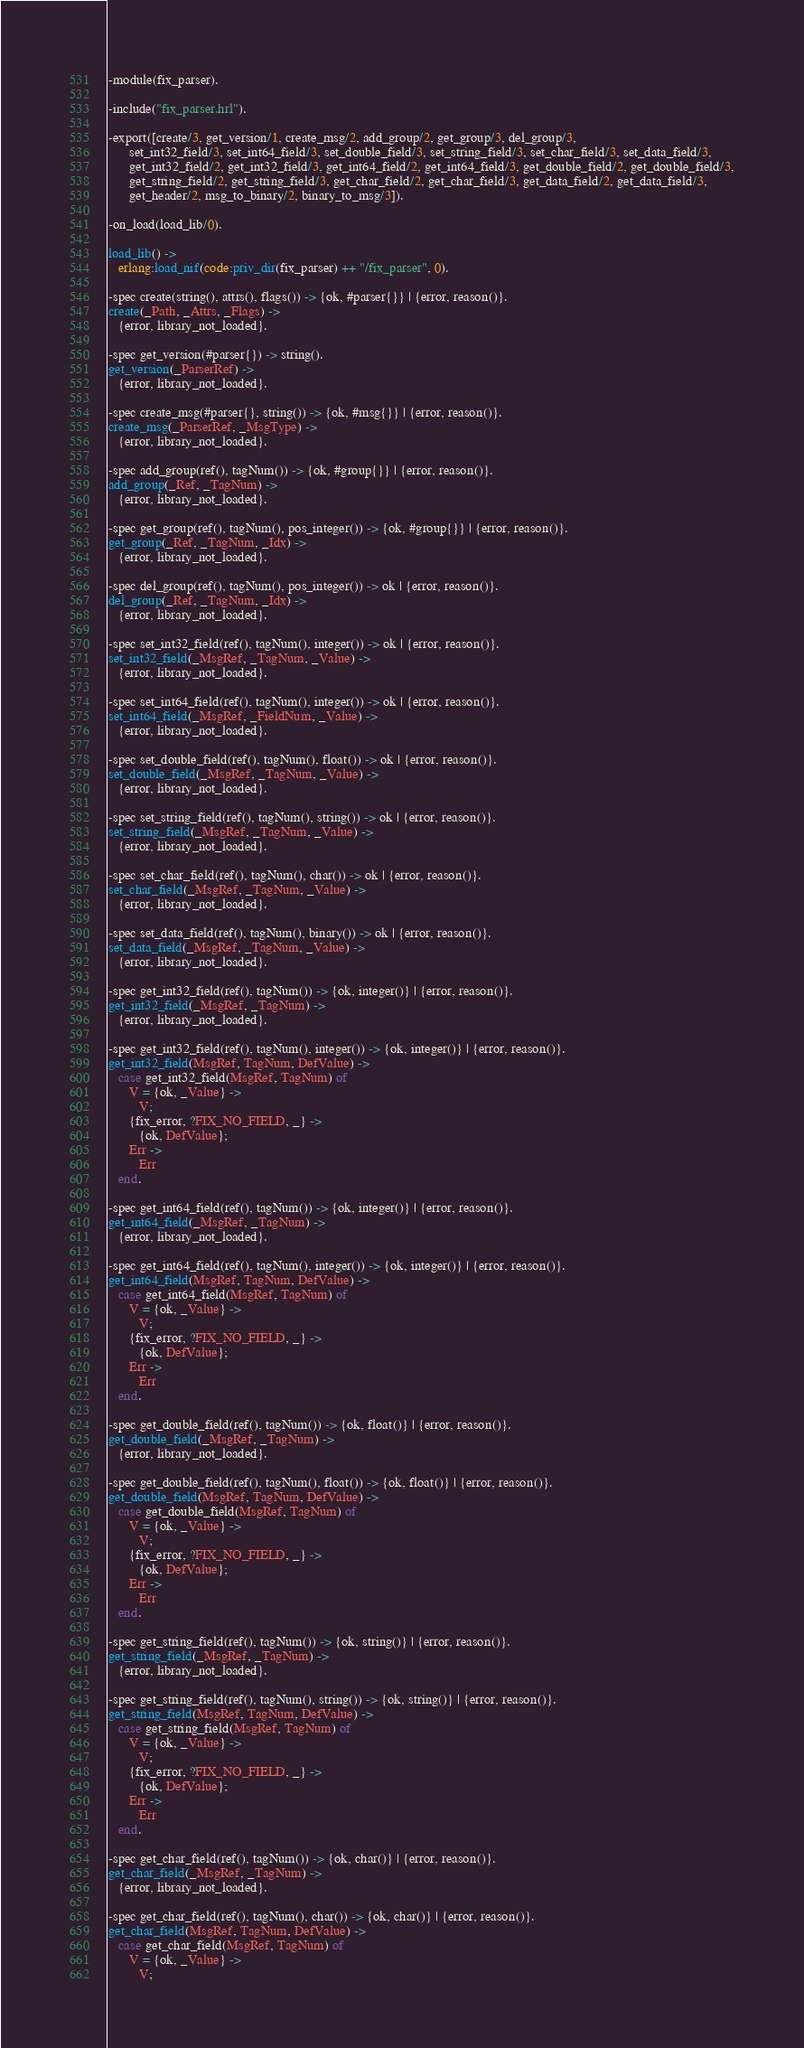Convert code to text. <code><loc_0><loc_0><loc_500><loc_500><_Erlang_>-module(fix_parser).

-include("fix_parser.hrl").

-export([create/3, get_version/1, create_msg/2, add_group/2, get_group/3, del_group/3,
      set_int32_field/3, set_int64_field/3, set_double_field/3, set_string_field/3, set_char_field/3, set_data_field/3,
      get_int32_field/2, get_int32_field/3, get_int64_field/2, get_int64_field/3, get_double_field/2, get_double_field/3,
      get_string_field/2, get_string_field/3, get_char_field/2, get_char_field/3, get_data_field/2, get_data_field/3,
      get_header/2, msg_to_binary/2, binary_to_msg/3]).

-on_load(load_lib/0).

load_lib() ->
   erlang:load_nif(code:priv_dir(fix_parser) ++ "/fix_parser", 0).

-spec create(string(), attrs(), flags()) -> {ok, #parser{}} | {error, reason()}.
create(_Path, _Attrs, _Flags) ->
   {error, library_not_loaded}.

-spec get_version(#parser{}) -> string().
get_version(_ParserRef) ->
   {error, library_not_loaded}.

-spec create_msg(#parser{}, string()) -> {ok, #msg{}} | {error, reason()}.
create_msg(_ParserRef, _MsgType) ->
   {error, library_not_loaded}.

-spec add_group(ref(), tagNum()) -> {ok, #group{}} | {error, reason()}.
add_group(_Ref, _TagNum) ->
   {error, library_not_loaded}.

-spec get_group(ref(), tagNum(), pos_integer()) -> {ok, #group{}} | {error, reason()}.
get_group(_Ref, _TagNum, _Idx) ->
   {error, library_not_loaded}.

-spec del_group(ref(), tagNum(), pos_integer()) -> ok | {error, reason()}.
del_group(_Ref, _TagNum, _Idx) ->
   {error, library_not_loaded}.

-spec set_int32_field(ref(), tagNum(), integer()) -> ok | {error, reason()}.
set_int32_field(_MsgRef, _TagNum, _Value) ->
   {error, library_not_loaded}.

-spec set_int64_field(ref(), tagNum(), integer()) -> ok | {error, reason()}.
set_int64_field(_MsgRef, _FieldNum, _Value) ->
   {error, library_not_loaded}.

-spec set_double_field(ref(), tagNum(), float()) -> ok | {error, reason()}.
set_double_field(_MsgRef, _TagNum, _Value) ->
   {error, library_not_loaded}.

-spec set_string_field(ref(), tagNum(), string()) -> ok | {error, reason()}.
set_string_field(_MsgRef, _TagNum, _Value) ->
   {error, library_not_loaded}.

-spec set_char_field(ref(), tagNum(), char()) -> ok | {error, reason()}.
set_char_field(_MsgRef, _TagNum, _Value) ->
   {error, library_not_loaded}.

-spec set_data_field(ref(), tagNum(), binary()) -> ok | {error, reason()}.
set_data_field(_MsgRef, _TagNum, _Value) ->
   {error, library_not_loaded}.

-spec get_int32_field(ref(), tagNum()) -> {ok, integer()} | {error, reason()}.
get_int32_field(_MsgRef, _TagNum) ->
   {error, library_not_loaded}.

-spec get_int32_field(ref(), tagNum(), integer()) -> {ok, integer()} | {error, reason()}.
get_int32_field(MsgRef, TagNum, DefValue) ->
   case get_int32_field(MsgRef, TagNum) of
      V = {ok, _Value} ->
         V;
      {fix_error, ?FIX_NO_FIELD, _} ->
         {ok, DefValue};
      Err ->
         Err
   end.

-spec get_int64_field(ref(), tagNum()) -> {ok, integer()} | {error, reason()}.
get_int64_field(_MsgRef, _TagNum) ->
   {error, library_not_loaded}.

-spec get_int64_field(ref(), tagNum(), integer()) -> {ok, integer()} | {error, reason()}.
get_int64_field(MsgRef, TagNum, DefValue) ->
   case get_int64_field(MsgRef, TagNum) of
      V = {ok, _Value} ->
         V;
      {fix_error, ?FIX_NO_FIELD, _} ->
         {ok, DefValue};
      Err ->
         Err
   end.

-spec get_double_field(ref(), tagNum()) -> {ok, float()} | {error, reason()}.
get_double_field(_MsgRef, _TagNum) ->
   {error, library_not_loaded}.

-spec get_double_field(ref(), tagNum(), float()) -> {ok, float()} | {error, reason()}.
get_double_field(MsgRef, TagNum, DefValue) ->
   case get_double_field(MsgRef, TagNum) of
      V = {ok, _Value} ->
         V;
      {fix_error, ?FIX_NO_FIELD, _} ->
         {ok, DefValue};
      Err ->
         Err
   end.

-spec get_string_field(ref(), tagNum()) -> {ok, string()} | {error, reason()}.
get_string_field(_MsgRef, _TagNum) ->
   {error, library_not_loaded}.

-spec get_string_field(ref(), tagNum(), string()) -> {ok, string()} | {error, reason()}.
get_string_field(MsgRef, TagNum, DefValue) ->
   case get_string_field(MsgRef, TagNum) of
      V = {ok, _Value} ->
         V;
      {fix_error, ?FIX_NO_FIELD, _} ->
         {ok, DefValue};
      Err ->
         Err
   end.

-spec get_char_field(ref(), tagNum()) -> {ok, char()} | {error, reason()}.
get_char_field(_MsgRef, _TagNum) ->
   {error, library_not_loaded}.

-spec get_char_field(ref(), tagNum(), char()) -> {ok, char()} | {error, reason()}.
get_char_field(MsgRef, TagNum, DefValue) ->
   case get_char_field(MsgRef, TagNum) of
      V = {ok, _Value} ->
         V;</code> 